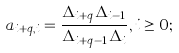<formula> <loc_0><loc_0><loc_500><loc_500>a _ { i + q , i } = \frac { \Delta _ { i + q } \Delta _ { i - 1 } } { \Delta _ { i + q - 1 } \Delta _ { i } } , i \geq 0 ;</formula> 